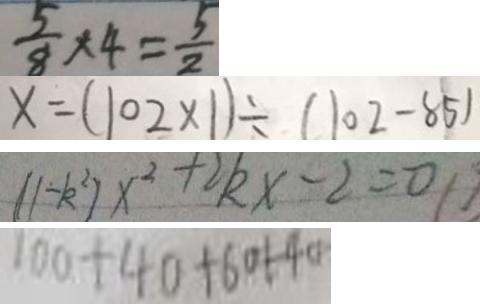<formula> <loc_0><loc_0><loc_500><loc_500>\frac { 5 } { 8 } \times 4 = \frac { 5 } { 2 } 
 x = ( 1 0 2 \times 1 ) \div ( 1 0 2 - 8 5 ) 
 ( 1 - k ^ { 2 } ) x ^ { 2 } + 2 k x - 2 = 0 
 1 0 a + 4 0 + 6 0 1 - 4 0</formula> 